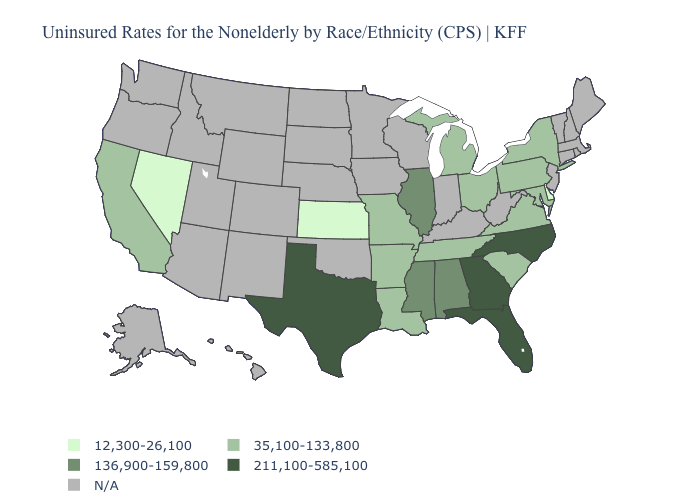Name the states that have a value in the range 211,100-585,100?
Keep it brief. Florida, Georgia, North Carolina, Texas. Name the states that have a value in the range 35,100-133,800?
Quick response, please. Arkansas, California, Louisiana, Maryland, Michigan, Missouri, New York, Ohio, Pennsylvania, South Carolina, Tennessee, Virginia. Does Kansas have the lowest value in the USA?
Give a very brief answer. Yes. Which states have the lowest value in the USA?
Answer briefly. Delaware, Kansas, Nevada. How many symbols are there in the legend?
Be succinct. 5. Does Delaware have the lowest value in the USA?
Give a very brief answer. Yes. What is the value of Tennessee?
Quick response, please. 35,100-133,800. What is the value of Rhode Island?
Keep it brief. N/A. Name the states that have a value in the range 12,300-26,100?
Answer briefly. Delaware, Kansas, Nevada. Among the states that border Nebraska , does Missouri have the lowest value?
Write a very short answer. No. What is the lowest value in the USA?
Give a very brief answer. 12,300-26,100. What is the lowest value in the USA?
Write a very short answer. 12,300-26,100. Name the states that have a value in the range N/A?
Short answer required. Alaska, Arizona, Colorado, Connecticut, Hawaii, Idaho, Indiana, Iowa, Kentucky, Maine, Massachusetts, Minnesota, Montana, Nebraska, New Hampshire, New Jersey, New Mexico, North Dakota, Oklahoma, Oregon, Rhode Island, South Dakota, Utah, Vermont, Washington, West Virginia, Wisconsin, Wyoming. What is the lowest value in the USA?
Be succinct. 12,300-26,100. Among the states that border Utah , which have the highest value?
Write a very short answer. Nevada. 